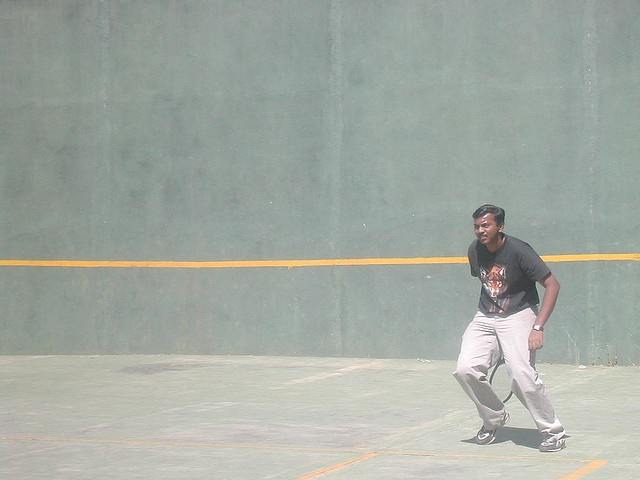Describe the objects in this image and their specific colors. I can see people in gray, lightgray, darkgray, and pink tones and tennis racket in gray, lightgray, and darkgray tones in this image. 